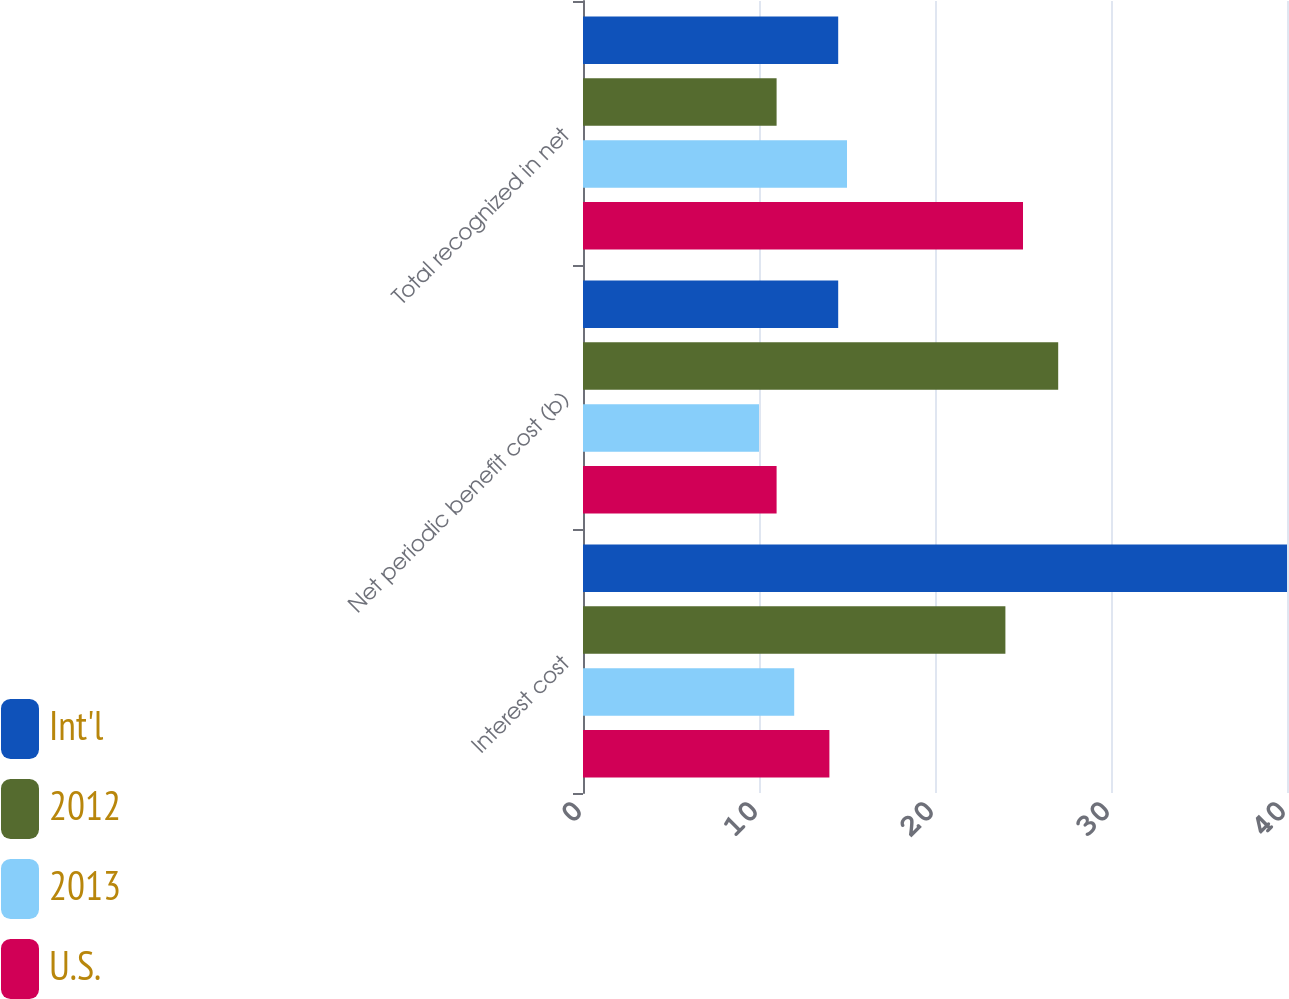<chart> <loc_0><loc_0><loc_500><loc_500><stacked_bar_chart><ecel><fcel>Interest cost<fcel>Net periodic benefit cost (b)<fcel>Total recognized in net<nl><fcel>Int'l<fcel>40<fcel>14.5<fcel>14.5<nl><fcel>2012<fcel>24<fcel>27<fcel>11<nl><fcel>2013<fcel>12<fcel>10<fcel>15<nl><fcel>U.S.<fcel>14<fcel>11<fcel>25<nl></chart> 